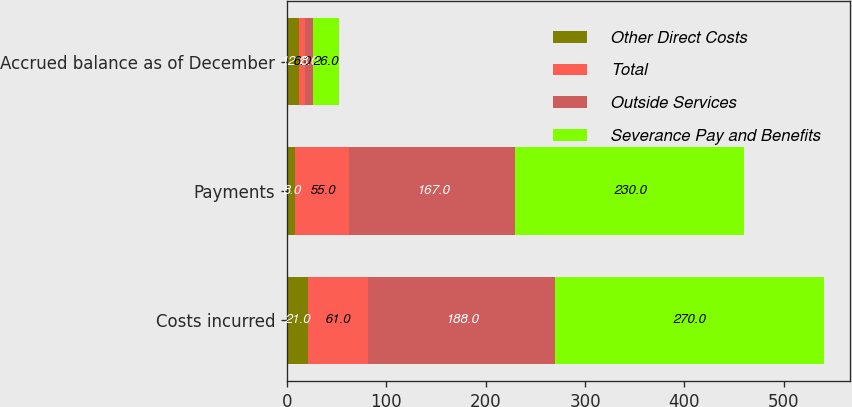Convert chart. <chart><loc_0><loc_0><loc_500><loc_500><stacked_bar_chart><ecel><fcel>Costs incurred<fcel>Payments<fcel>Accrued balance as of December<nl><fcel>Other Direct Costs<fcel>21<fcel>8<fcel>12<nl><fcel>Total<fcel>61<fcel>55<fcel>6<nl><fcel>Outside Services<fcel>188<fcel>167<fcel>8<nl><fcel>Severance Pay and Benefits<fcel>270<fcel>230<fcel>26<nl></chart> 